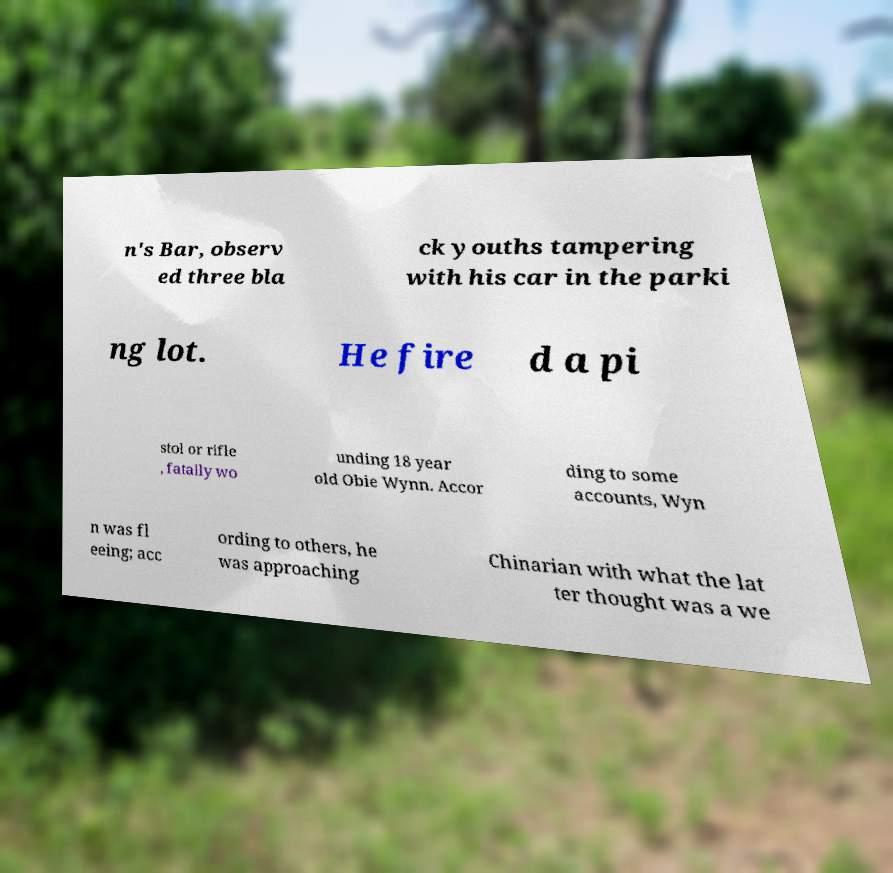Could you extract and type out the text from this image? n's Bar, observ ed three bla ck youths tampering with his car in the parki ng lot. He fire d a pi stol or rifle , fatally wo unding 18 year old Obie Wynn. Accor ding to some accounts, Wyn n was fl eeing; acc ording to others, he was approaching Chinarian with what the lat ter thought was a we 